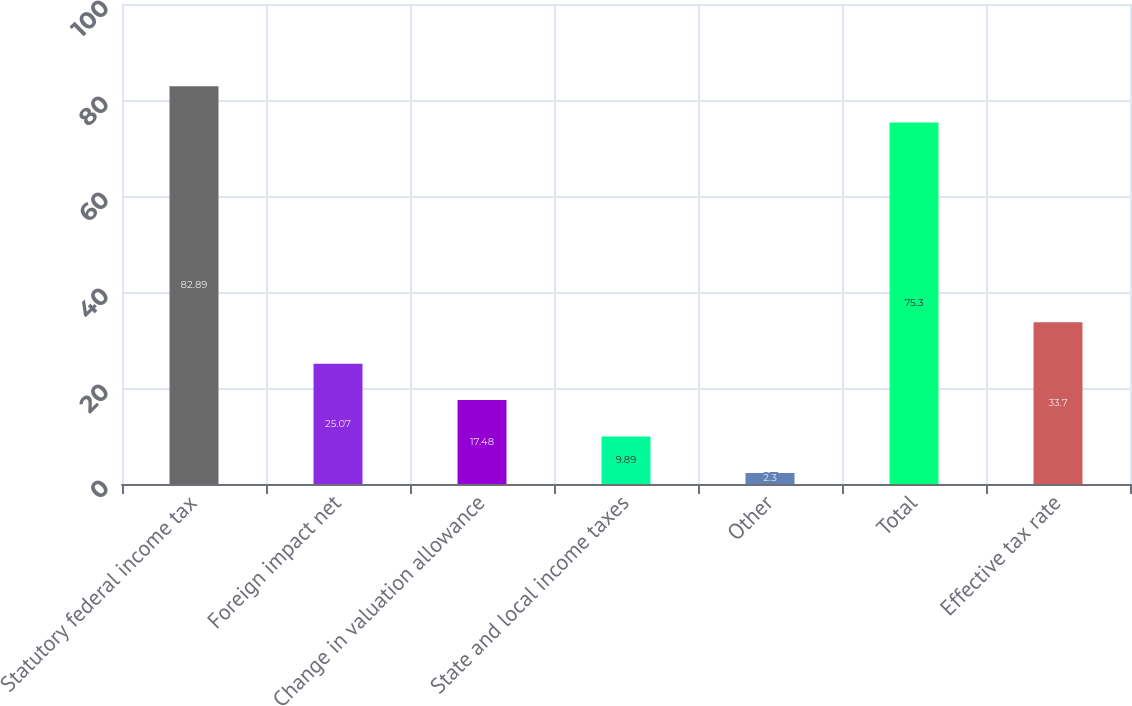Convert chart. <chart><loc_0><loc_0><loc_500><loc_500><bar_chart><fcel>Statutory federal income tax<fcel>Foreign impact net<fcel>Change in valuation allowance<fcel>State and local income taxes<fcel>Other<fcel>Total<fcel>Effective tax rate<nl><fcel>82.89<fcel>25.07<fcel>17.48<fcel>9.89<fcel>2.3<fcel>75.3<fcel>33.7<nl></chart> 